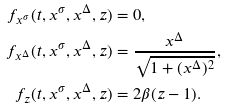Convert formula to latex. <formula><loc_0><loc_0><loc_500><loc_500>f _ { x ^ { \sigma } } ( t , x ^ { \sigma } , x ^ { \Delta } , z ) & = 0 , \\ f _ { x ^ { \Delta } } ( t , x ^ { \sigma } , x ^ { \Delta } , z ) & = \frac { x ^ { \Delta } } { \sqrt { 1 + ( x ^ { \Delta } ) ^ { 2 } } } , \\ f _ { z } ( t , x ^ { \sigma } , x ^ { \Delta } , z ) & = 2 \beta ( z - 1 ) .</formula> 